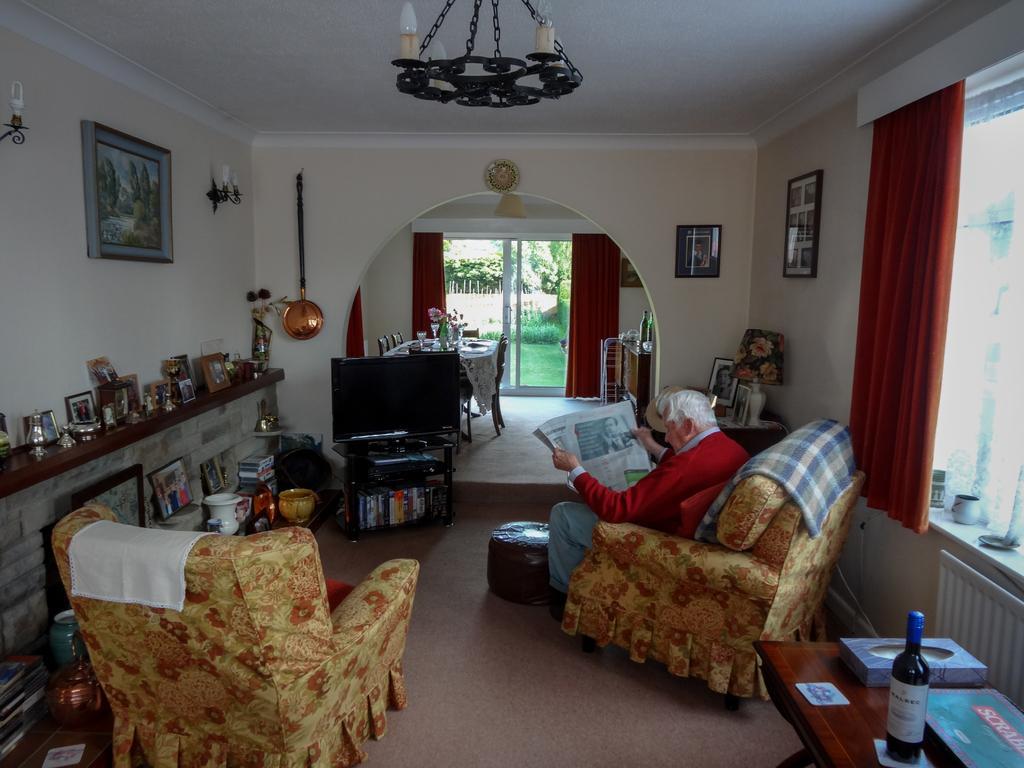How would you summarize this image in a sentence or two? In the image we can see there is a man who is sitting on chair and reading newspaper and there is a tv in the room and there are lot of decorative items on the table rack. 